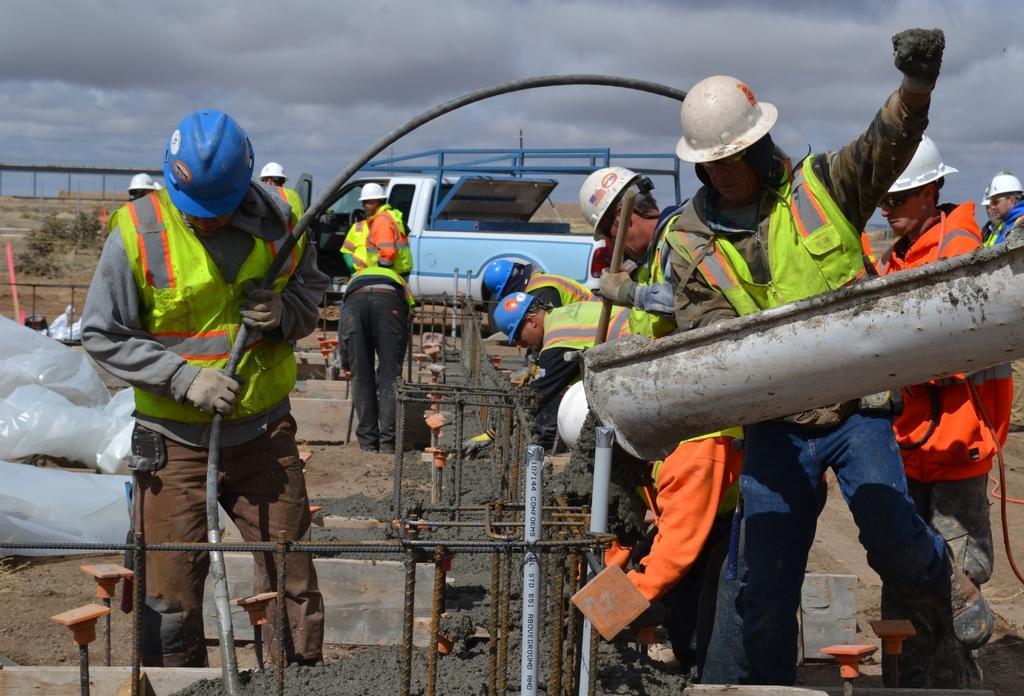How would you summarize this image in a sentence or two? In this image there are group of people standing , iron rods, pipes, cement, a vehicle , grass, plants, covers, sky. 